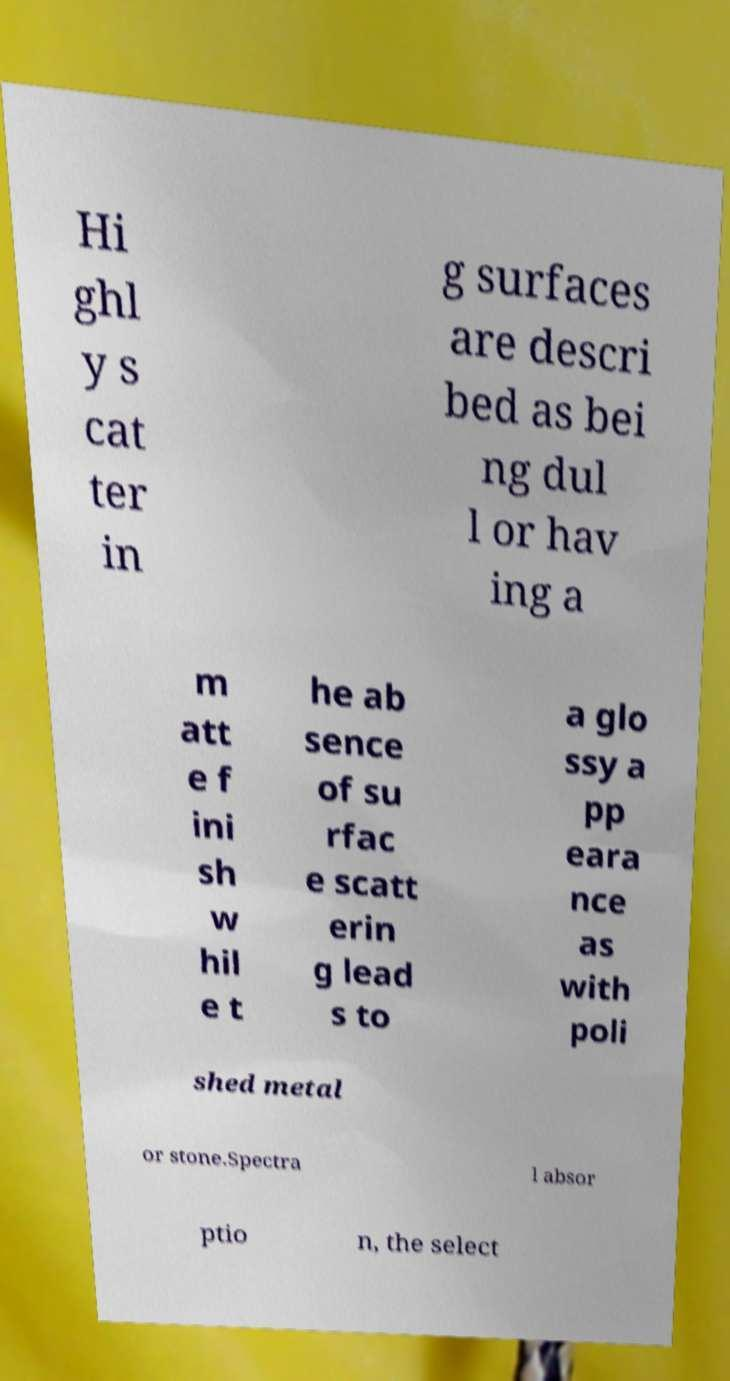Can you accurately transcribe the text from the provided image for me? Hi ghl y s cat ter in g surfaces are descri bed as bei ng dul l or hav ing a m att e f ini sh w hil e t he ab sence of su rfac e scatt erin g lead s to a glo ssy a pp eara nce as with poli shed metal or stone.Spectra l absor ptio n, the select 